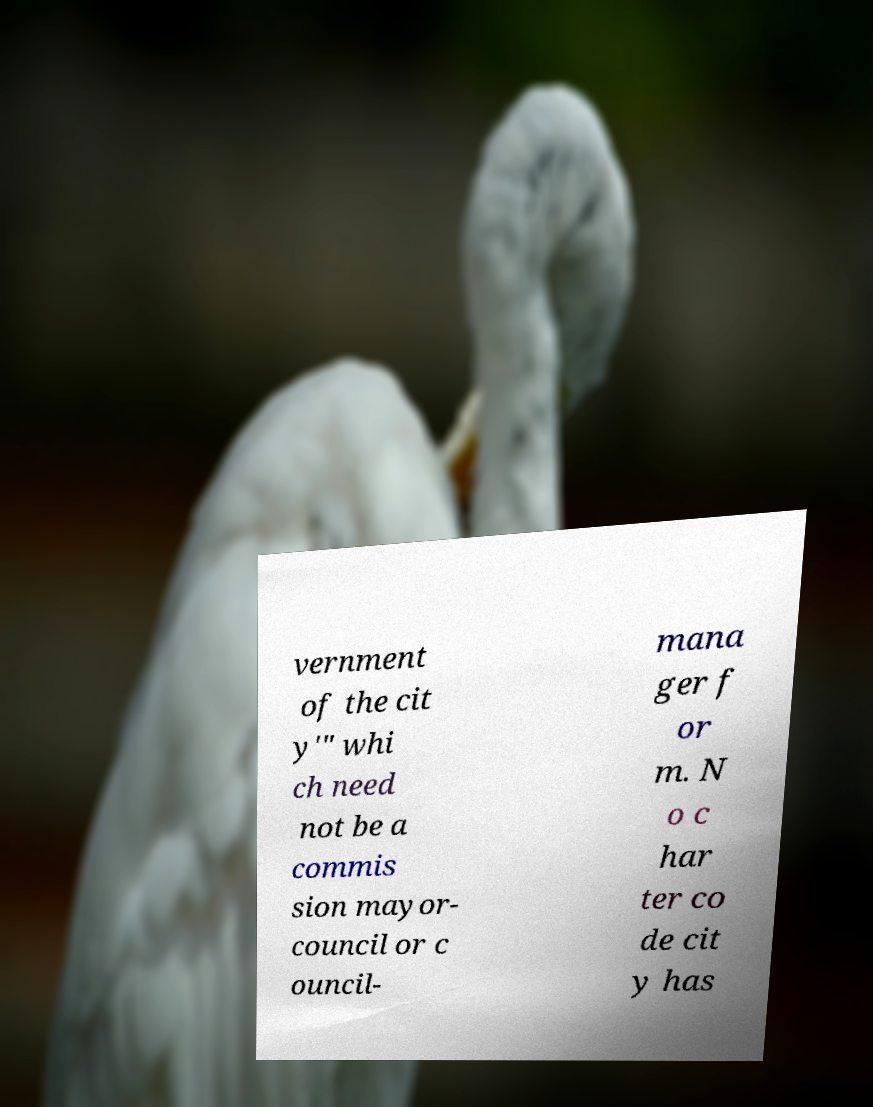Can you accurately transcribe the text from the provided image for me? vernment of the cit y'" whi ch need not be a commis sion mayor- council or c ouncil- mana ger f or m. N o c har ter co de cit y has 